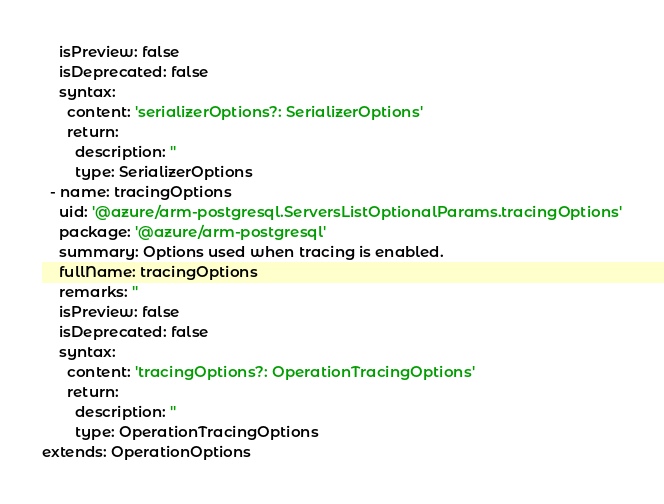Convert code to text. <code><loc_0><loc_0><loc_500><loc_500><_YAML_>    isPreview: false
    isDeprecated: false
    syntax:
      content: 'serializerOptions?: SerializerOptions'
      return:
        description: ''
        type: SerializerOptions
  - name: tracingOptions
    uid: '@azure/arm-postgresql.ServersListOptionalParams.tracingOptions'
    package: '@azure/arm-postgresql'
    summary: Options used when tracing is enabled.
    fullName: tracingOptions
    remarks: ''
    isPreview: false
    isDeprecated: false
    syntax:
      content: 'tracingOptions?: OperationTracingOptions'
      return:
        description: ''
        type: OperationTracingOptions
extends: OperationOptions
</code> 